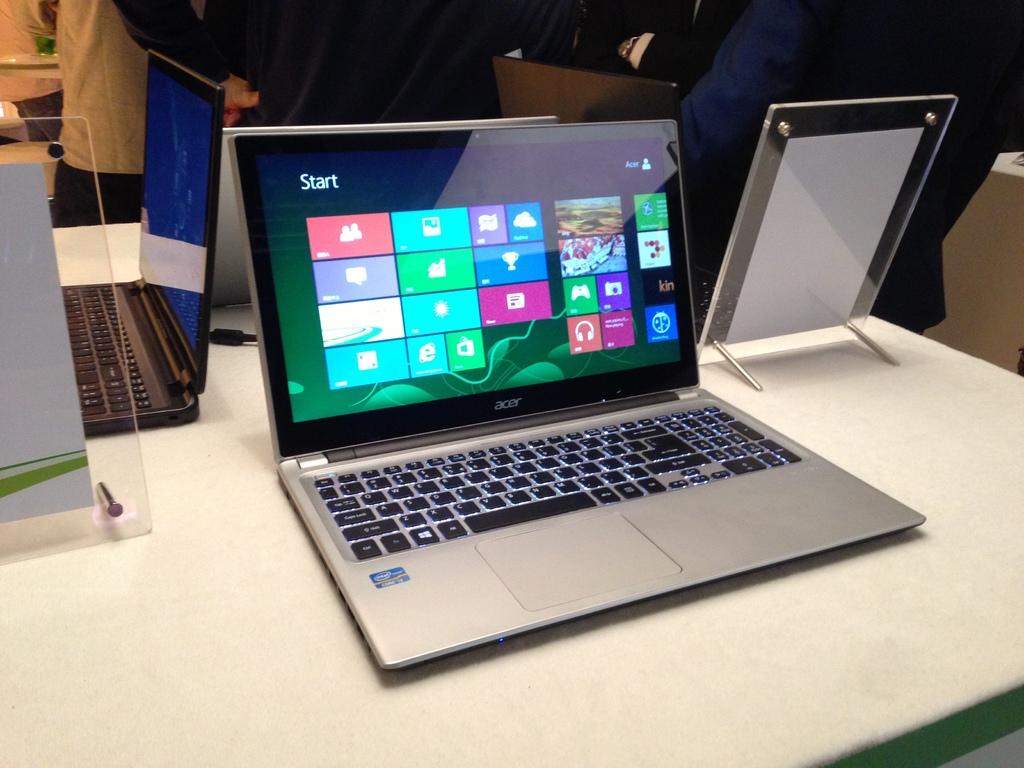<image>
Share a concise interpretation of the image provided. A silver Acer laptop is displayed on a white counter. 